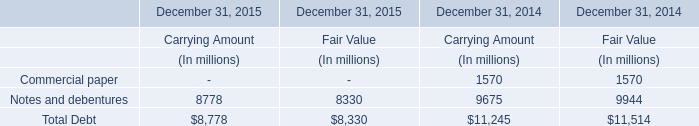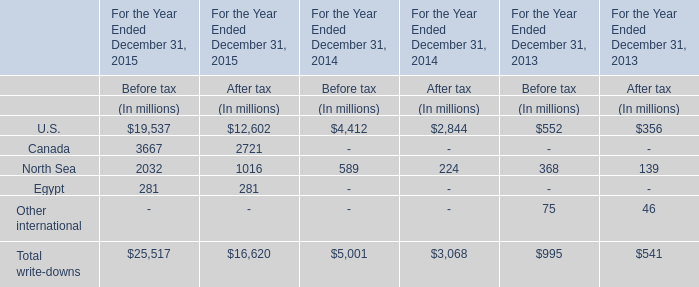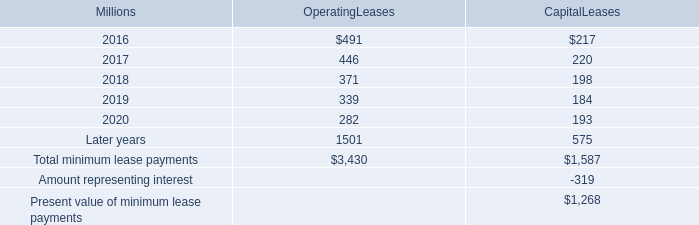What's the sum of the Total write-downs in the years where North Sea is positive? 
Computations: (((((25517 + 16620) + 5001) + 3068) + 995) + 541)
Answer: 51742.0. 